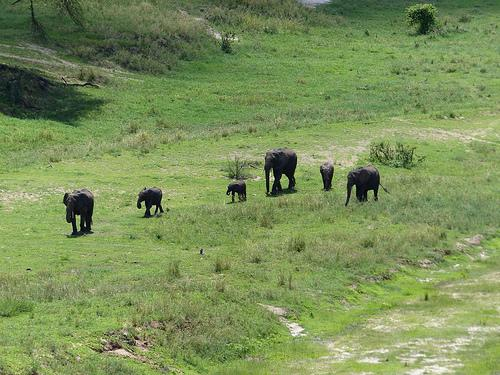Question: what are they doing?
Choices:
A. Standing.
B. Sitting.
C. Walking.
D. Sleeping.
Answer with the letter. Answer: C Question: how many baby elephants?
Choices:
A. One.
B. Two.
C. Four.
D. Three.
Answer with the letter. Answer: D Question: who is leading the pack?
Choices:
A. The male.
B. The wolf.
C. An adult elephant.
D. The fastest runner.
Answer with the letter. Answer: C Question: what roaming the grass?
Choices:
A. Deer.
B. Lions.
C. Elephants.
D. Tigers.
Answer with the letter. Answer: C Question: where are the elephants?
Choices:
A. The jungle.
B. The open field.
C. Africa.
D. Asia.
Answer with the letter. Answer: B Question: how many elephants are there?
Choices:
A. One.
B. Six.
C. Two.
D. Three.
Answer with the letter. Answer: B 